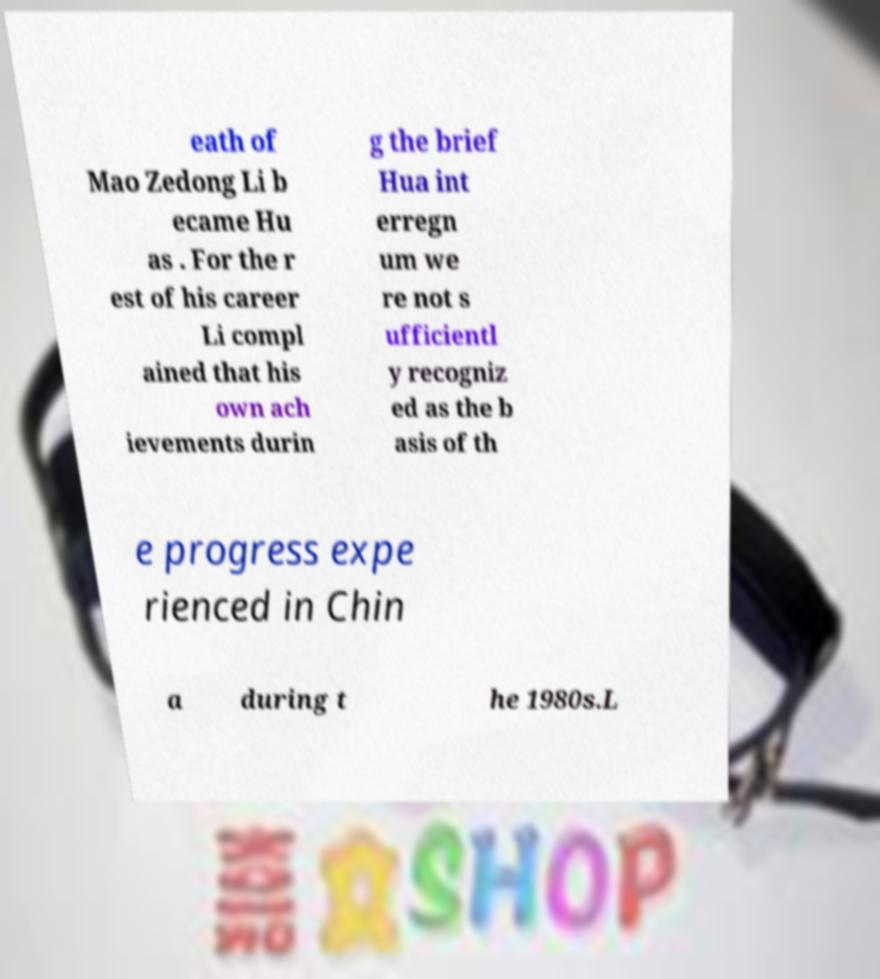Please identify and transcribe the text found in this image. eath of Mao Zedong Li b ecame Hu as . For the r est of his career Li compl ained that his own ach ievements durin g the brief Hua int erregn um we re not s ufficientl y recogniz ed as the b asis of th e progress expe rienced in Chin a during t he 1980s.L 